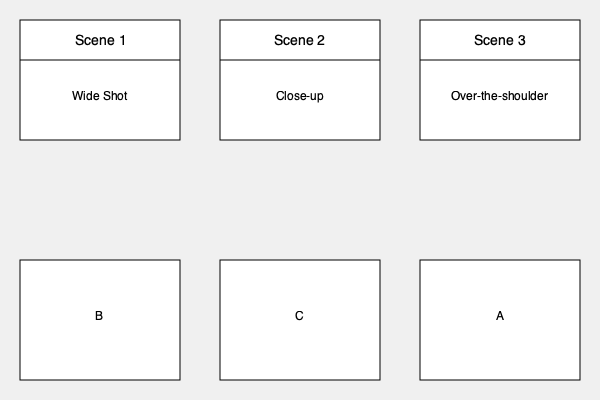Match the storyboard scenes (1, 2, 3) with their corresponding camera angles (A, B, C) based on the visual information provided. What is the correct sequence of camera angles for scenes 1, 2, and 3? To solve this problem, we need to analyze each storyboard and match it with the appropriate camera angle:

1. Scene 1 is labeled as a "Wide Shot". Looking at the camera angles, we can see that option B shows the widest view, capturing the most of the scene. Therefore, Scene 1 matches with camera angle B.

2. Scene 2 is labeled as a "Close-up". Among the camera angles, option C shows the tightest framing, focusing on a single character or object. This corresponds to a close-up shot. Thus, Scene 2 matches with camera angle C.

3. Scene 3 is labeled as an "Over-the-shoulder" shot. In the camera angles, option A shows a composition where we see part of one character's shoulder in the foreground, with the focus on another character or object in the background. This is characteristic of an over-the-shoulder shot. Therefore, Scene 3 matches with camera angle A.

Arranging these matches in the order of the scenes (1, 2, 3), we get the sequence: B, C, A.
Answer: B, C, A 